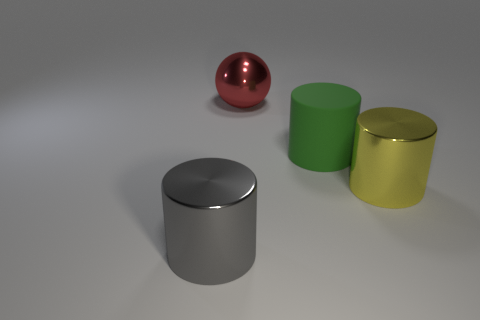Subtract all blue balls. Subtract all red cubes. How many balls are left? 1 Subtract all red cubes. How many blue cylinders are left? 0 Add 2 big yellows. How many big objects exist? 0 Subtract all large yellow objects. Subtract all cyan shiny cubes. How many objects are left? 3 Add 3 big shiny spheres. How many big shiny spheres are left? 4 Add 3 large green cylinders. How many large green cylinders exist? 4 Add 2 red metal balls. How many objects exist? 6 Subtract all green cylinders. How many cylinders are left? 2 Subtract all green rubber cylinders. How many cylinders are left? 2 Subtract 0 gray cubes. How many objects are left? 4 